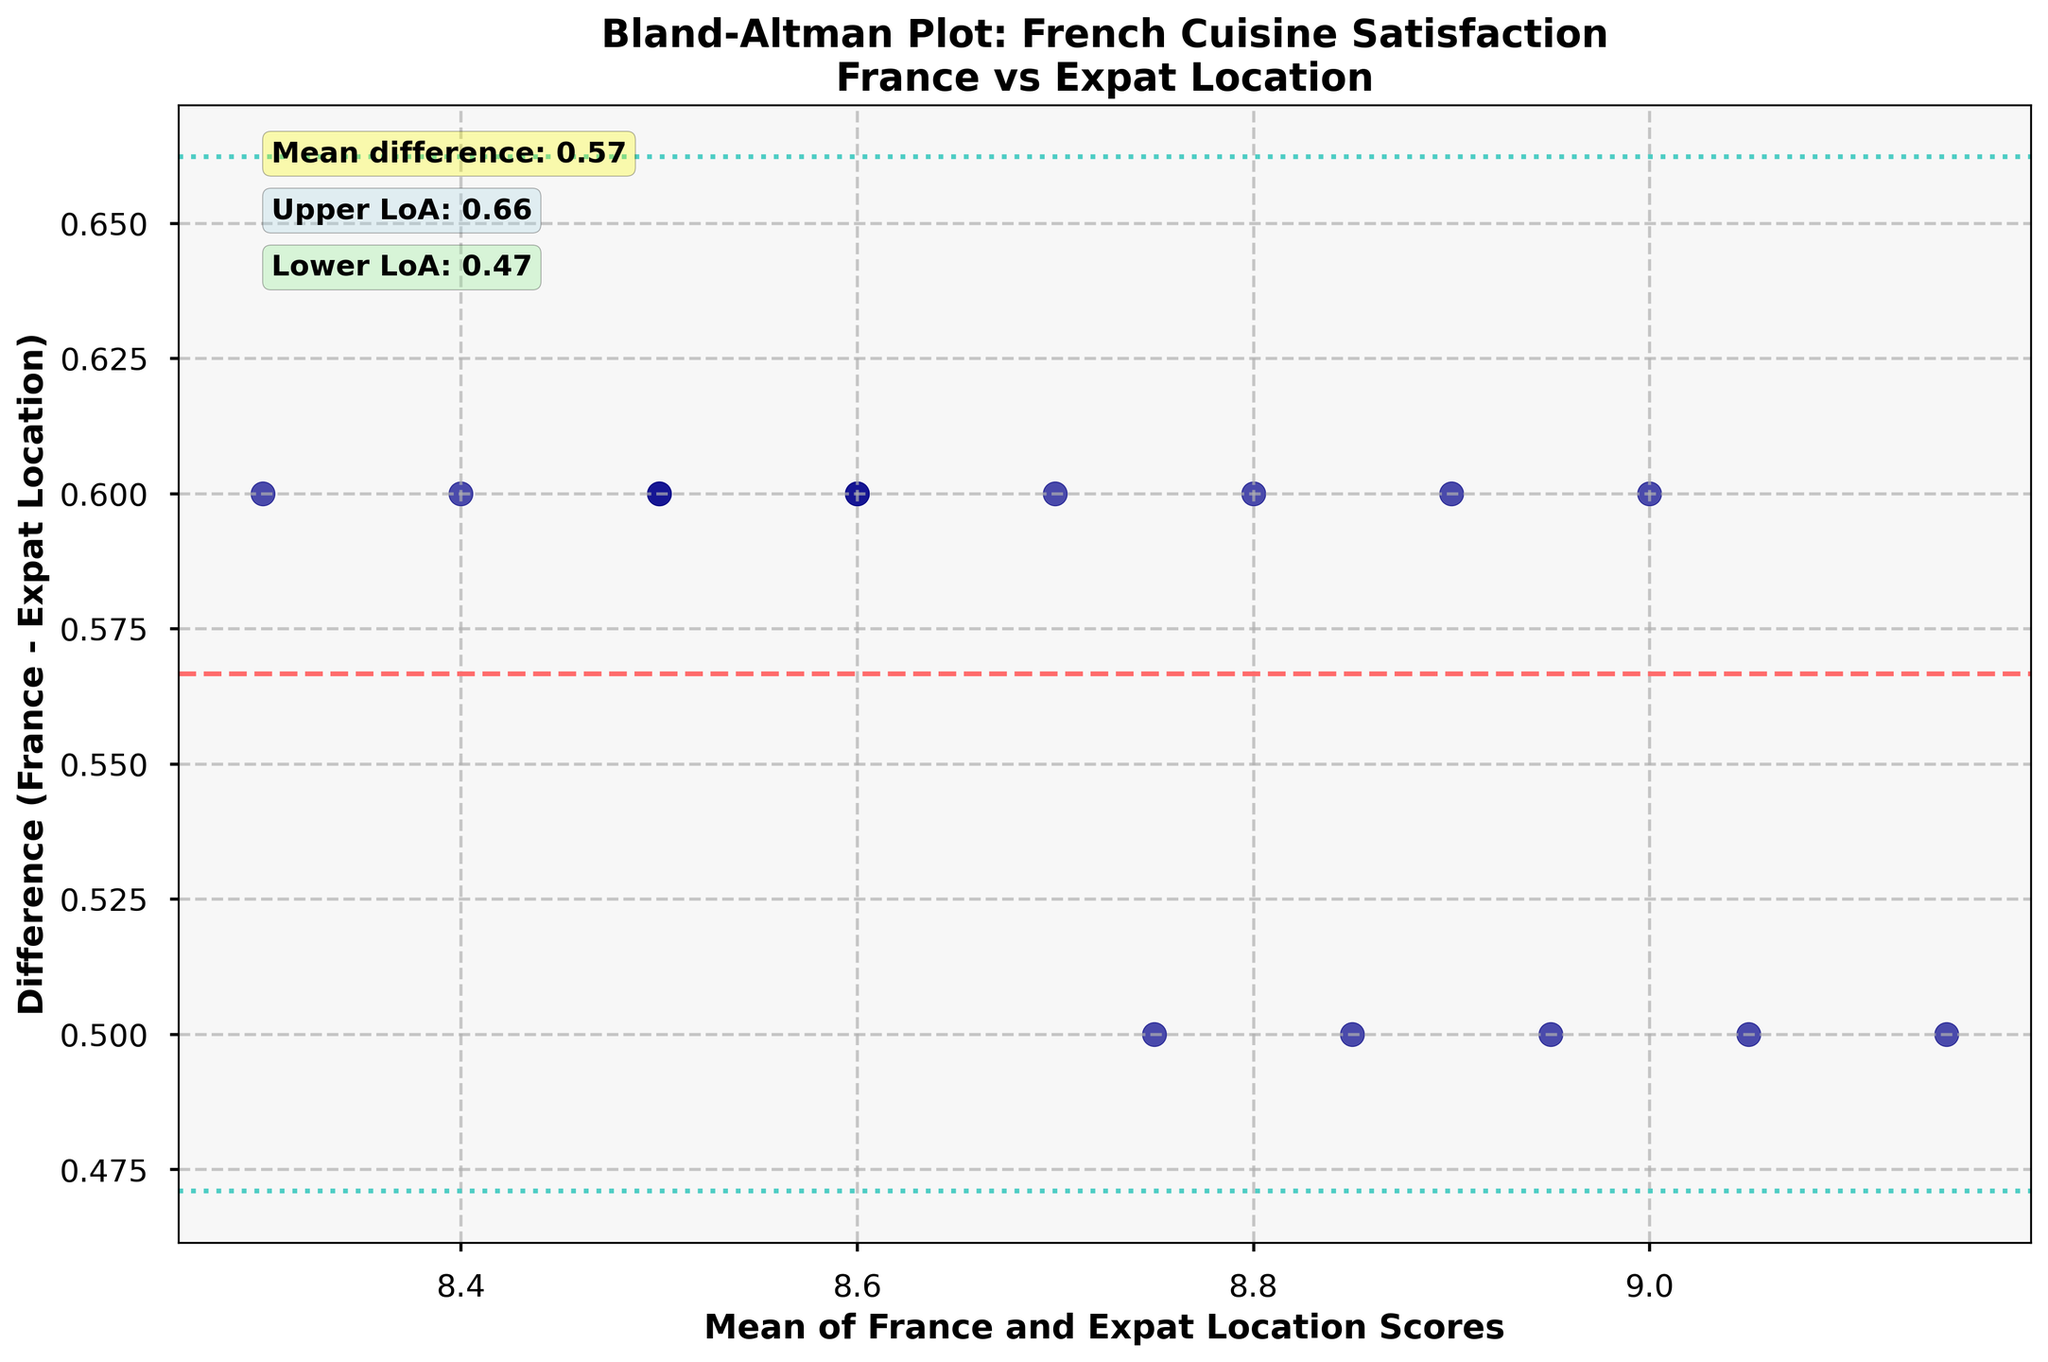How many data points are represented in the plot? By counting the number of points (dots) on the plot, you can determine the total number of data points. Each dot represents a restaurant's customer satisfaction score comparison between France and the expat location.
Answer: 15 What is the title of the plot? The title is usually located at the top center of the plot, providing a summary of what the plot represents.
Answer: Bland-Altman Plot: French Cuisine Satisfaction France vs Expat Location What do the horizontal dashed lines represent? The horizontal dashed lines in a Bland–Altman plot typically represent the mean difference and limits of agreement. These lines help assess the agreement between two sets of measurements.
Answer: Mean difference, Upper LoA, Lower LoA What's the mean difference in satisfaction scores between France and the expat location? The mean difference can be seen directly from the annotation near the top left corner of the plot. It is also represented by the central horizontal dashed line.
Answer: 0.57 Are there any data points that fall outside the limits of agreement? To determine this, observe if any points (dots) fall outside the horizontal dashed lines that represent the upper and lower limits of agreement.
Answer: No How are the axes labeled? The x-axis and y-axis labels can typically be found directly next to the respective axes.
Answer: Mean of France and Expat Location Scores (x-axis), Difference (France - Expat Location) (y-axis) What does a positive value on the y-axis indicate about the satisfaction score comparison? A positive value on the y-axis indicates that the customer satisfaction score in France is higher than that in the expat location.
Answer: France score is higher Which restaurant has the highest mean score of France and expat location combined? To find this, identify the point on the plot that is furthest along the x-axis and further cross-check against the restaurant list for the highest mean value.
Answer: Septime What's the range of the limits of agreement? The limits of agreement are given by two horizontal dashed lines, the values can be read from the annotations or ax lines intersection with y-axis. Calculate the difference between the upper and lower limits annotated.
Answer: 1.38 